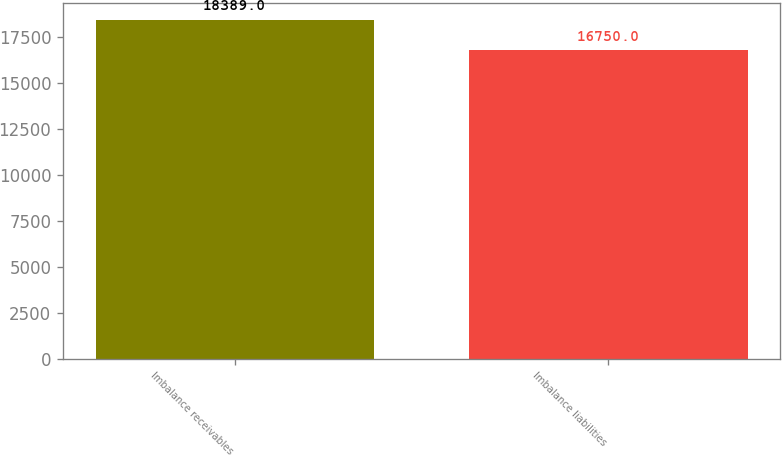Convert chart. <chart><loc_0><loc_0><loc_500><loc_500><bar_chart><fcel>Imbalance receivables<fcel>Imbalance liabilities<nl><fcel>18389<fcel>16750<nl></chart> 